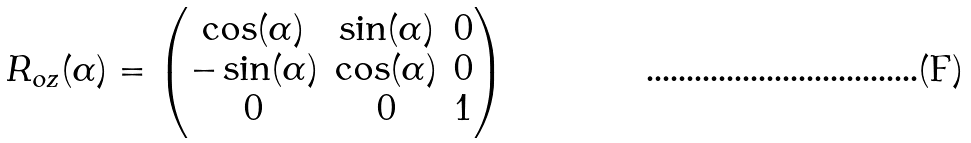Convert formula to latex. <formula><loc_0><loc_0><loc_500><loc_500>R _ { o { z } } ( \alpha ) = \begin{pmatrix} \cos ( \alpha ) & \sin ( \alpha ) & 0 \\ - \sin ( \alpha ) & \cos ( \alpha ) & 0 \\ 0 & 0 & 1 \end{pmatrix}</formula> 